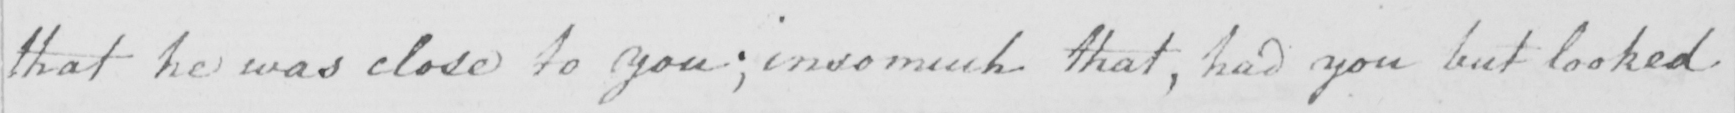Can you read and transcribe this handwriting? that he was close to you ; insomuch that , had you but looked 